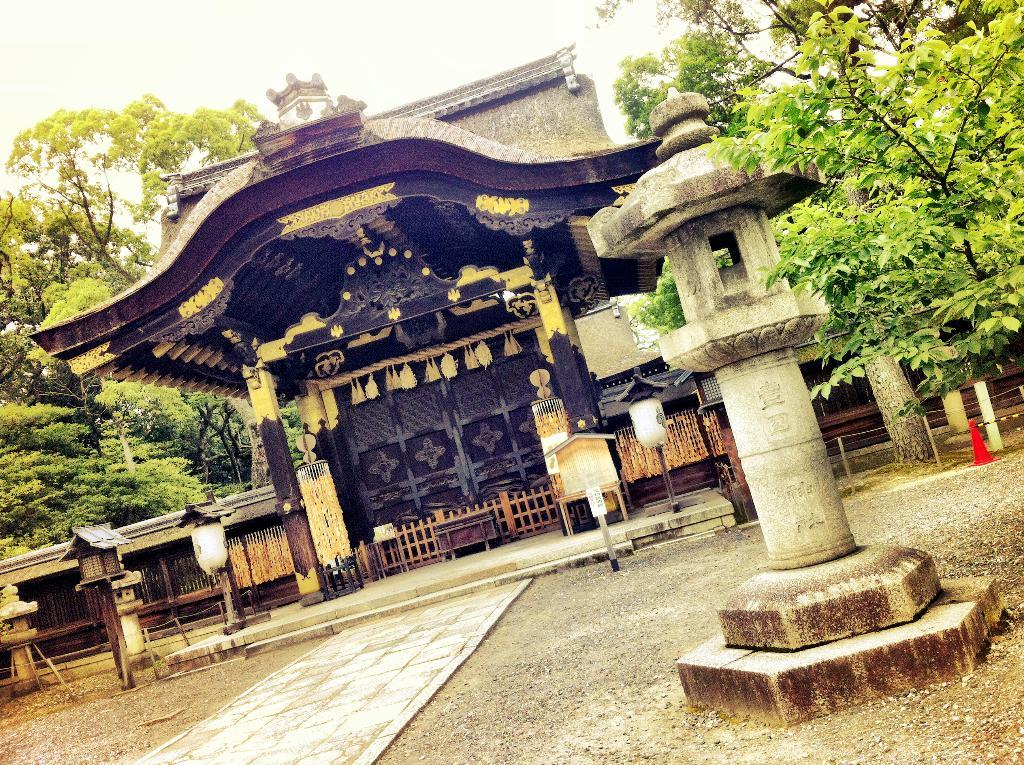What type of surface can be seen in the image? There is a path in the image. What type of man-made structures are present in the image? There is architecture and a building in the image. What type of natural elements are present in the image? There are trees in the image. What type of objects are present in the image? There are boxes and other objects in the image. What can be seen in the background of the image? The sky is visible in the background of the image. What is the tax rate for the building in the image? There is no information about tax rates in the image; it only shows a building, a path, trees, boxes, and other objects. What rhythm is being played by the trees in the image? There is no rhythm being played by the trees in the image; they are stationary natural elements. 